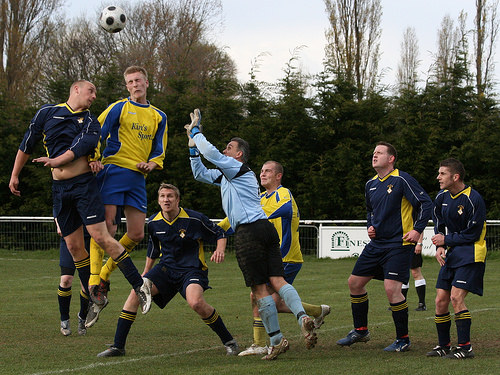<image>
Is there a ball behind the man? No. The ball is not behind the man. From this viewpoint, the ball appears to be positioned elsewhere in the scene. Is the ball in front of the player? No. The ball is not in front of the player. The spatial positioning shows a different relationship between these objects. 